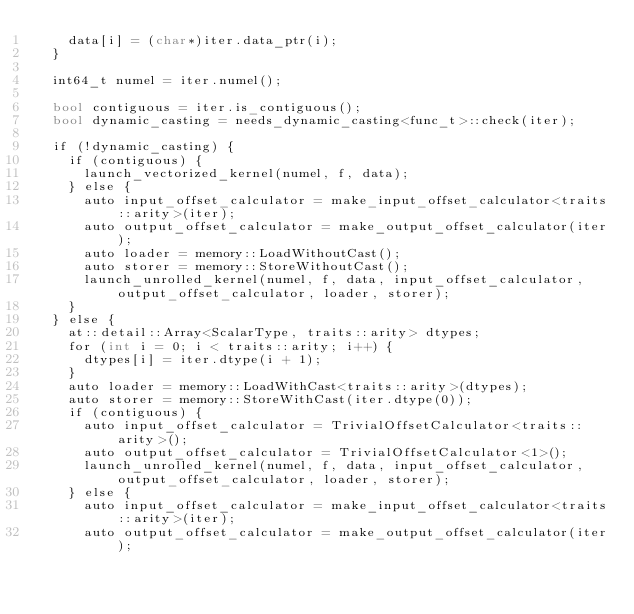<code> <loc_0><loc_0><loc_500><loc_500><_Cuda_>    data[i] = (char*)iter.data_ptr(i);
  }

  int64_t numel = iter.numel();

  bool contiguous = iter.is_contiguous();
  bool dynamic_casting = needs_dynamic_casting<func_t>::check(iter);

  if (!dynamic_casting) {
    if (contiguous) {
      launch_vectorized_kernel(numel, f, data);
    } else {
      auto input_offset_calculator = make_input_offset_calculator<traits::arity>(iter);
      auto output_offset_calculator = make_output_offset_calculator(iter);
      auto loader = memory::LoadWithoutCast();
      auto storer = memory::StoreWithoutCast();
      launch_unrolled_kernel(numel, f, data, input_offset_calculator, output_offset_calculator, loader, storer);
    }
  } else {
    at::detail::Array<ScalarType, traits::arity> dtypes;
    for (int i = 0; i < traits::arity; i++) {
      dtypes[i] = iter.dtype(i + 1);
    }
    auto loader = memory::LoadWithCast<traits::arity>(dtypes);
    auto storer = memory::StoreWithCast(iter.dtype(0));
    if (contiguous) {
      auto input_offset_calculator = TrivialOffsetCalculator<traits::arity>();
      auto output_offset_calculator = TrivialOffsetCalculator<1>();
      launch_unrolled_kernel(numel, f, data, input_offset_calculator, output_offset_calculator, loader, storer);
    } else {
      auto input_offset_calculator = make_input_offset_calculator<traits::arity>(iter);
      auto output_offset_calculator = make_output_offset_calculator(iter);</code> 